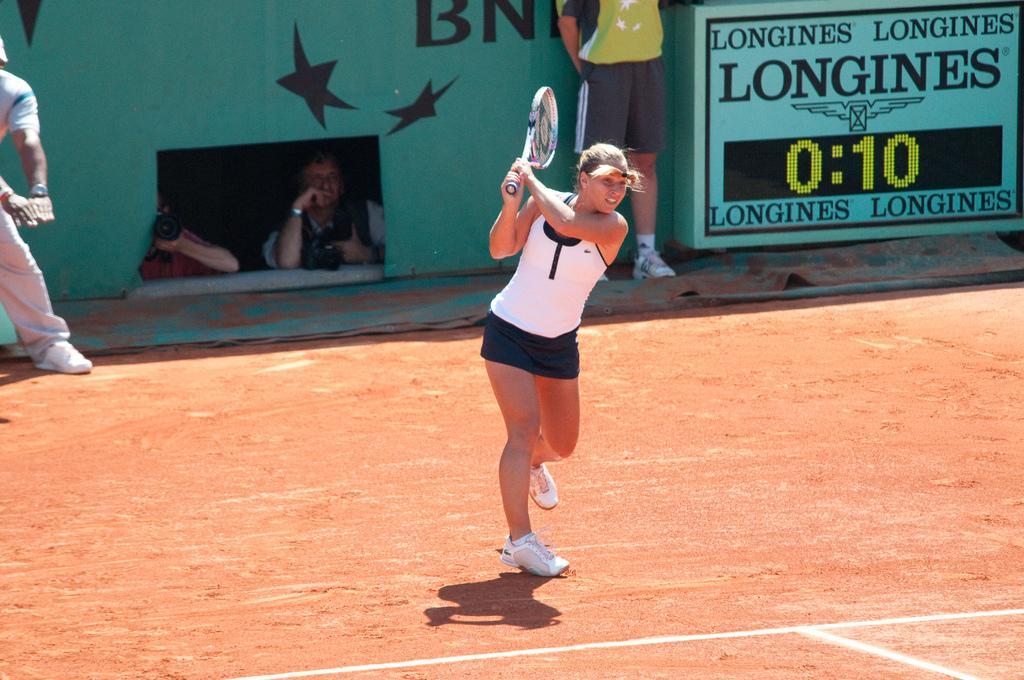How would you summarize this image in a sentence or two? In this image i can see a woman is holding a tennis bat in her hand. I can also see there are few people behind this woman. 